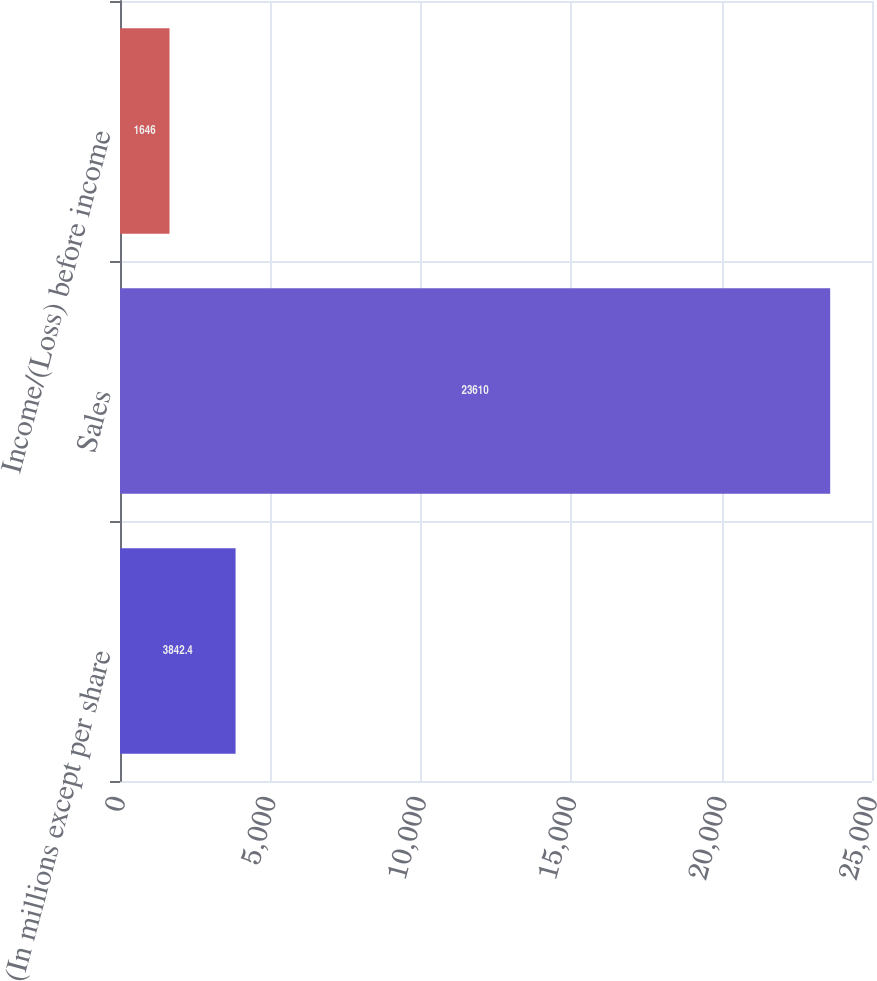<chart> <loc_0><loc_0><loc_500><loc_500><bar_chart><fcel>(In millions except per share<fcel>Sales<fcel>Income/(Loss) before income<nl><fcel>3842.4<fcel>23610<fcel>1646<nl></chart> 